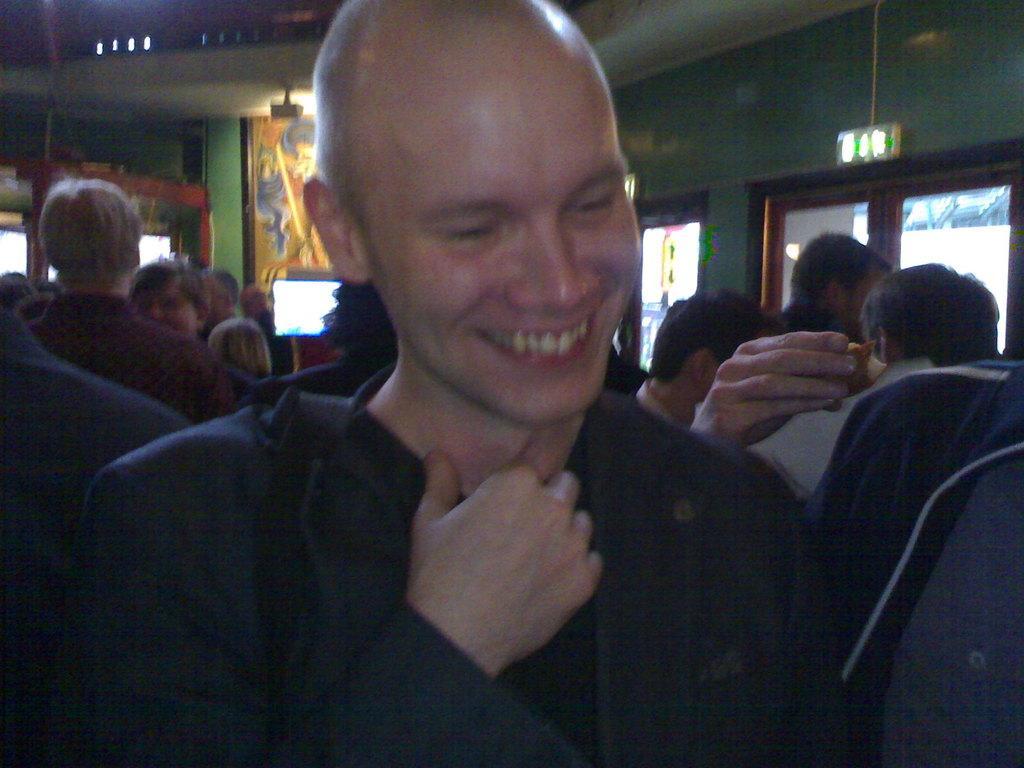Can you describe this image briefly? This picture shows few people standing and we see a television and a frame on the wall and we see a man with a smile on his face and we see a human hand holding some food and we see a glass door. 